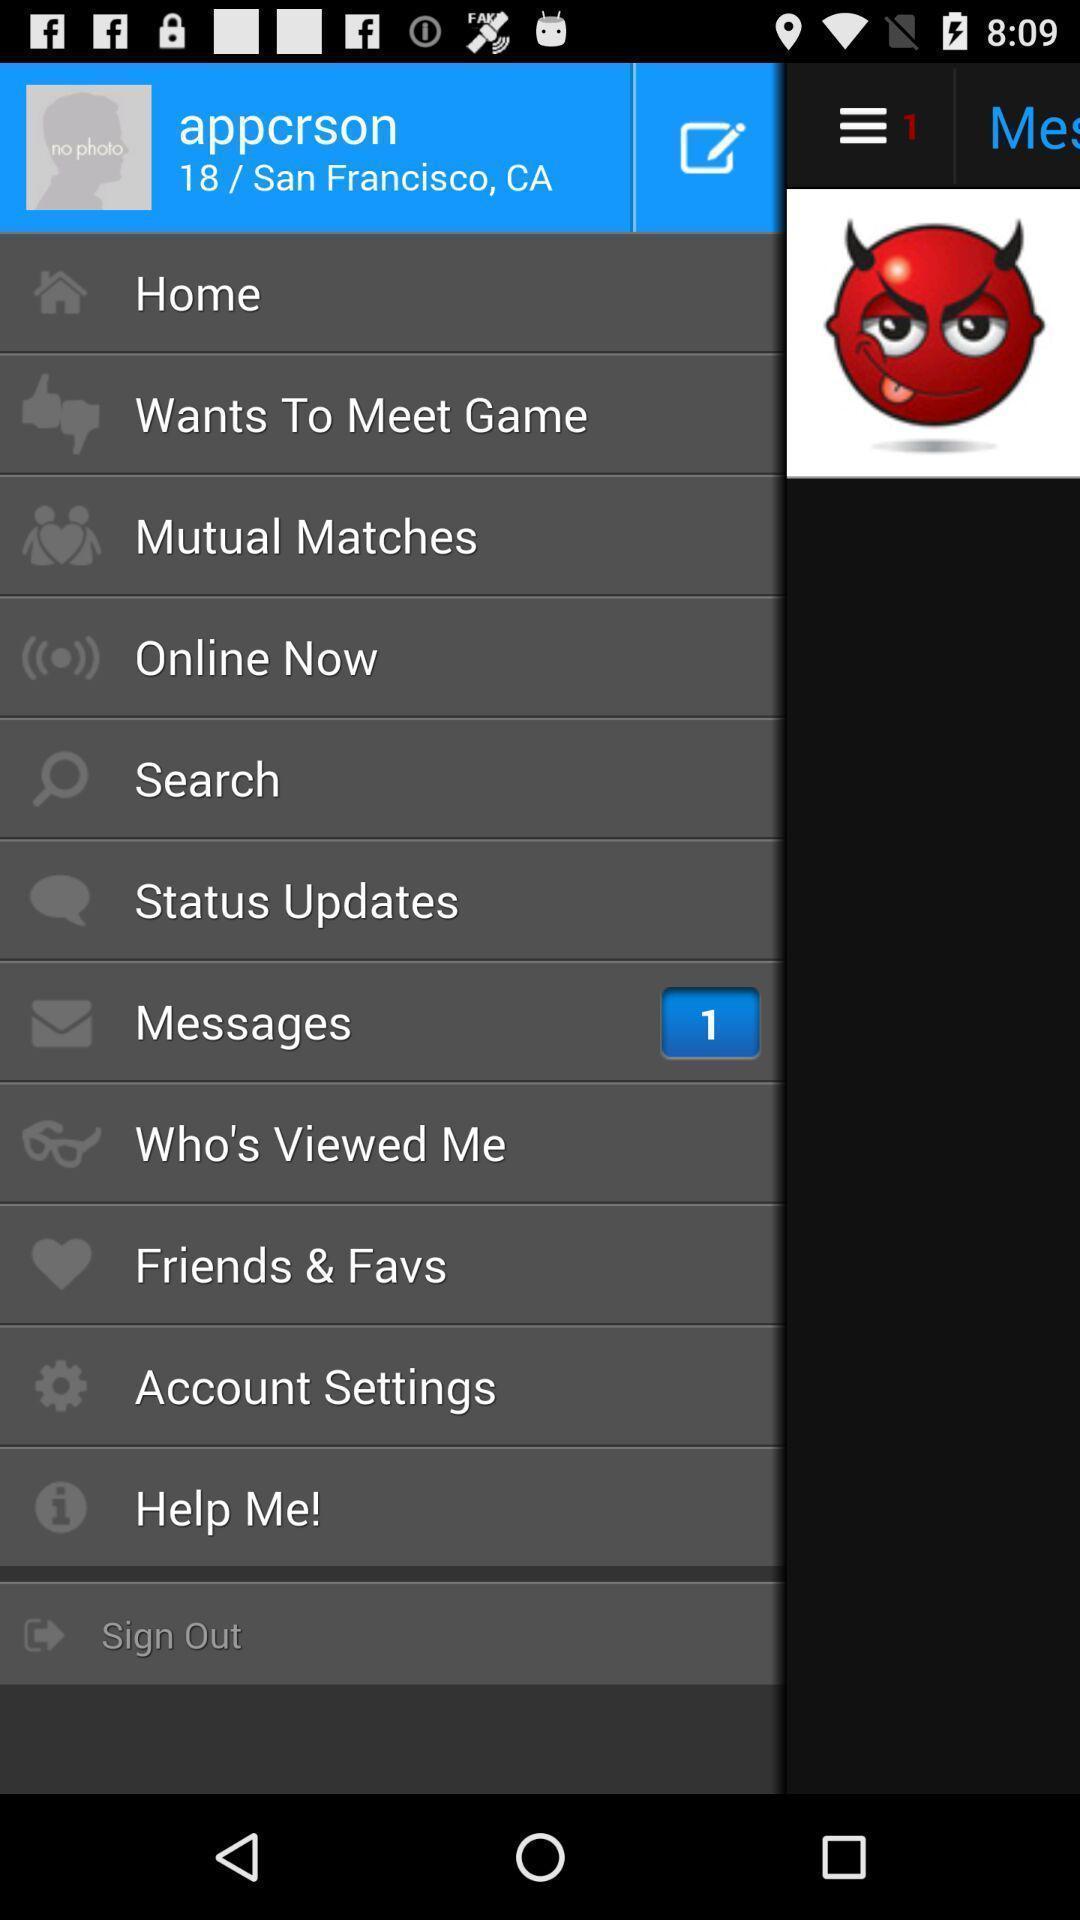Please provide a description for this image. Screen displaying user information with multiple icons and names. 